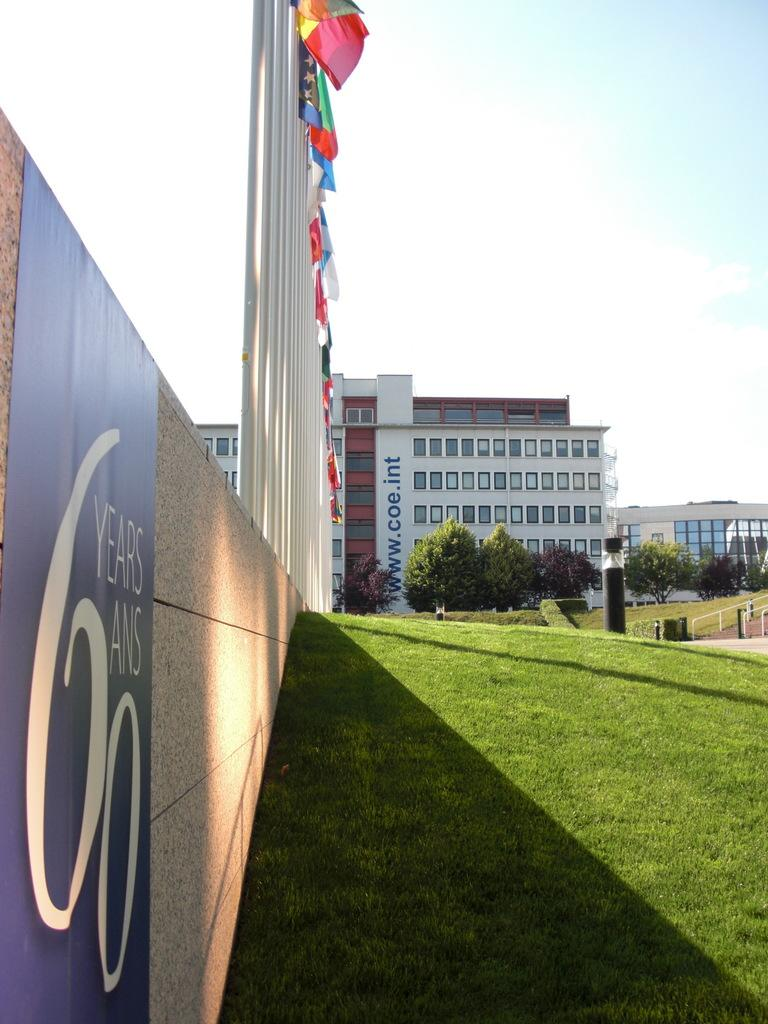<image>
Provide a brief description of the given image. a sign next to some grass that has the letter 6 on it 